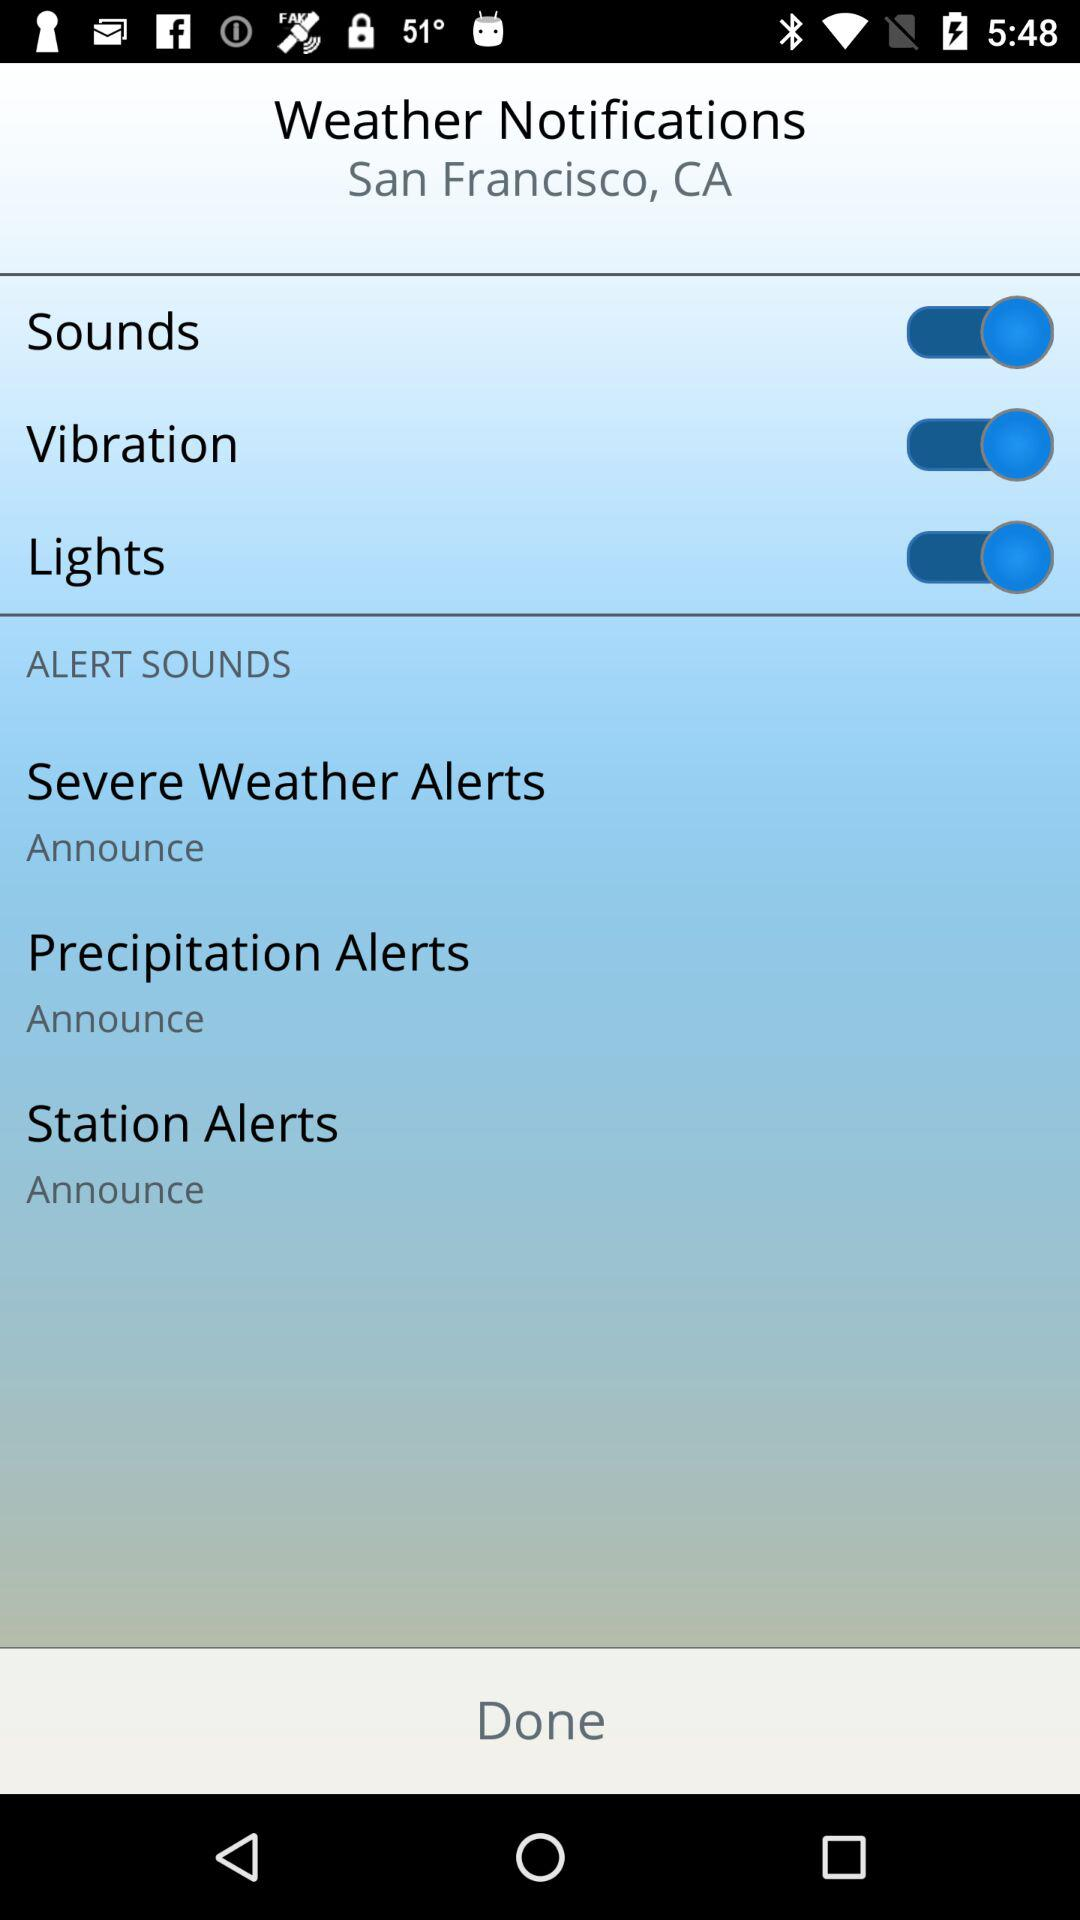What city name is displayed on the screen? The city name is San Francisco. 